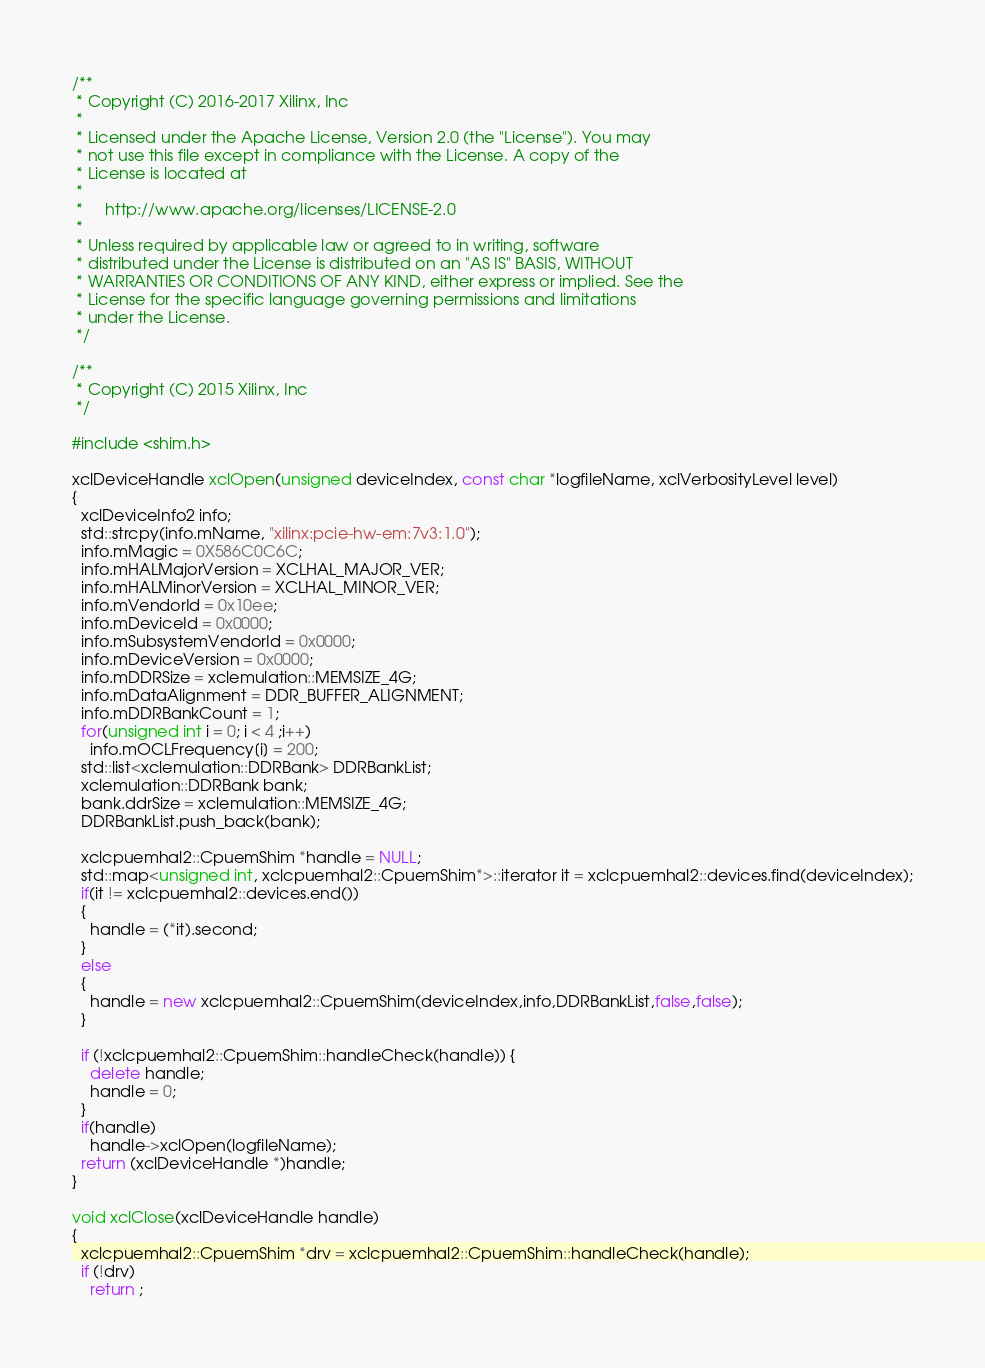<code> <loc_0><loc_0><loc_500><loc_500><_C++_>/**
 * Copyright (C) 2016-2017 Xilinx, Inc
 *
 * Licensed under the Apache License, Version 2.0 (the "License"). You may
 * not use this file except in compliance with the License. A copy of the
 * License is located at
 *
 *     http://www.apache.org/licenses/LICENSE-2.0
 *
 * Unless required by applicable law or agreed to in writing, software
 * distributed under the License is distributed on an "AS IS" BASIS, WITHOUT
 * WARRANTIES OR CONDITIONS OF ANY KIND, either express or implied. See the
 * License for the specific language governing permissions and limitations
 * under the License.
 */

/**
 * Copyright (C) 2015 Xilinx, Inc
 */

#include <shim.h>
 
xclDeviceHandle xclOpen(unsigned deviceIndex, const char *logfileName, xclVerbosityLevel level)
{
  xclDeviceInfo2 info;
  std::strcpy(info.mName, "xilinx:pcie-hw-em:7v3:1.0");
  info.mMagic = 0X586C0C6C;
  info.mHALMajorVersion = XCLHAL_MAJOR_VER;
  info.mHALMinorVersion = XCLHAL_MINOR_VER;
  info.mVendorId = 0x10ee;
  info.mDeviceId = 0x0000;
  info.mSubsystemVendorId = 0x0000;
  info.mDeviceVersion = 0x0000;
  info.mDDRSize = xclemulation::MEMSIZE_4G;
  info.mDataAlignment = DDR_BUFFER_ALIGNMENT;
  info.mDDRBankCount = 1;
  for(unsigned int i = 0; i < 4 ;i++)
    info.mOCLFrequency[i] = 200;
  std::list<xclemulation::DDRBank> DDRBankList;
  xclemulation::DDRBank bank;
  bank.ddrSize = xclemulation::MEMSIZE_4G;
  DDRBankList.push_back(bank);

  xclcpuemhal2::CpuemShim *handle = NULL;
  std::map<unsigned int, xclcpuemhal2::CpuemShim*>::iterator it = xclcpuemhal2::devices.find(deviceIndex);
  if(it != xclcpuemhal2::devices.end())
  {
    handle = (*it).second;
  }
  else
  {
    handle = new xclcpuemhal2::CpuemShim(deviceIndex,info,DDRBankList,false,false);
  }

  if (!xclcpuemhal2::CpuemShim::handleCheck(handle)) {
    delete handle;
    handle = 0;
  }
  if(handle)
    handle->xclOpen(logfileName);
  return (xclDeviceHandle *)handle;
}

void xclClose(xclDeviceHandle handle)
{
  xclcpuemhal2::CpuemShim *drv = xclcpuemhal2::CpuemShim::handleCheck(handle);
  if (!drv)
    return ;</code> 